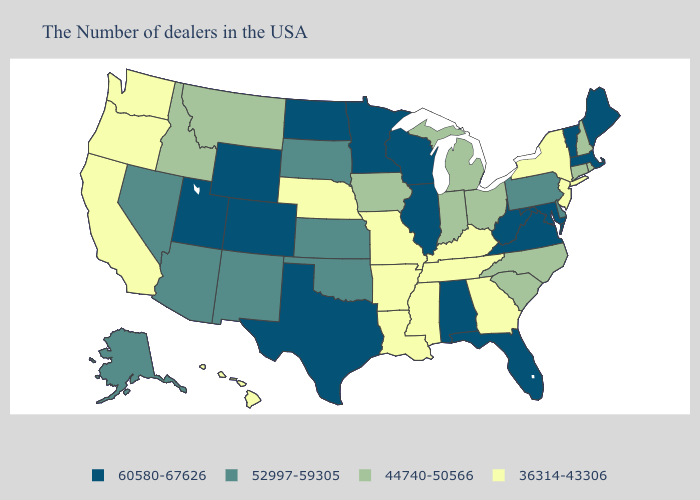What is the value of Oregon?
Give a very brief answer. 36314-43306. What is the lowest value in states that border Kentucky?
Give a very brief answer. 36314-43306. Does New Hampshire have the highest value in the Northeast?
Keep it brief. No. What is the lowest value in the Northeast?
Give a very brief answer. 36314-43306. Name the states that have a value in the range 52997-59305?
Quick response, please. Delaware, Pennsylvania, Kansas, Oklahoma, South Dakota, New Mexico, Arizona, Nevada, Alaska. Does Mississippi have the highest value in the South?
Quick response, please. No. Among the states that border Tennessee , does Missouri have the lowest value?
Write a very short answer. Yes. What is the value of North Dakota?
Answer briefly. 60580-67626. Which states have the highest value in the USA?
Write a very short answer. Maine, Massachusetts, Vermont, Maryland, Virginia, West Virginia, Florida, Alabama, Wisconsin, Illinois, Minnesota, Texas, North Dakota, Wyoming, Colorado, Utah. Name the states that have a value in the range 36314-43306?
Keep it brief. New York, New Jersey, Georgia, Kentucky, Tennessee, Mississippi, Louisiana, Missouri, Arkansas, Nebraska, California, Washington, Oregon, Hawaii. What is the value of North Dakota?
Short answer required. 60580-67626. What is the value of Nebraska?
Answer briefly. 36314-43306. What is the value of Iowa?
Give a very brief answer. 44740-50566. Does Missouri have the highest value in the USA?
Be succinct. No. Name the states that have a value in the range 52997-59305?
Be succinct. Delaware, Pennsylvania, Kansas, Oklahoma, South Dakota, New Mexico, Arizona, Nevada, Alaska. 